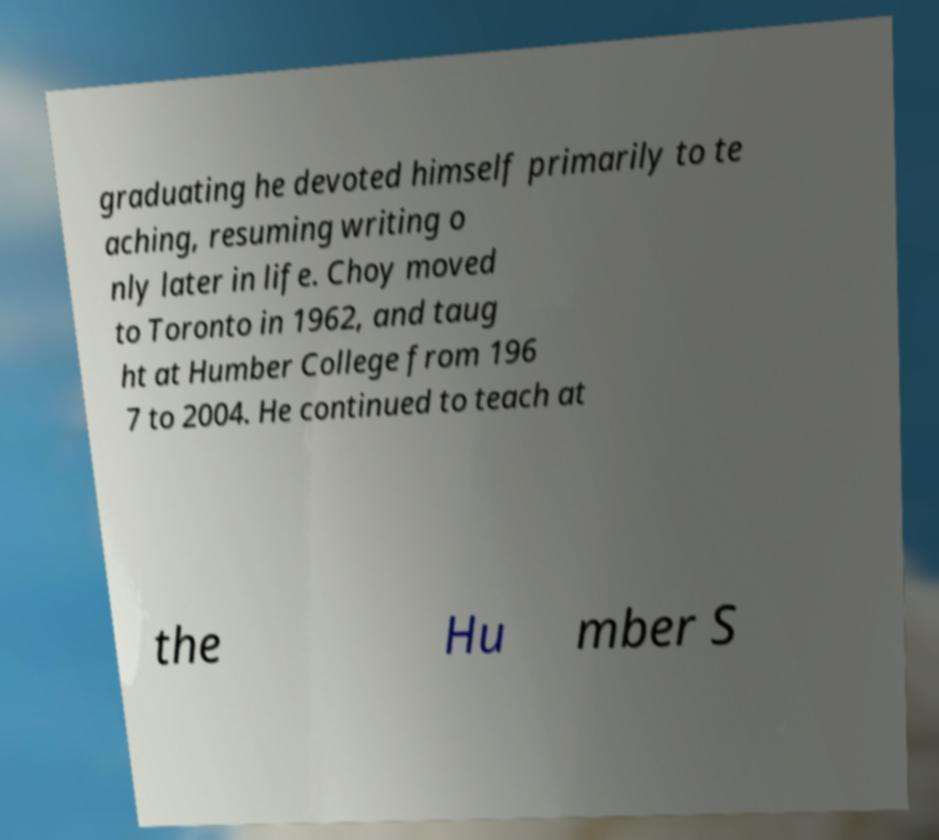For documentation purposes, I need the text within this image transcribed. Could you provide that? graduating he devoted himself primarily to te aching, resuming writing o nly later in life. Choy moved to Toronto in 1962, and taug ht at Humber College from 196 7 to 2004. He continued to teach at the Hu mber S 